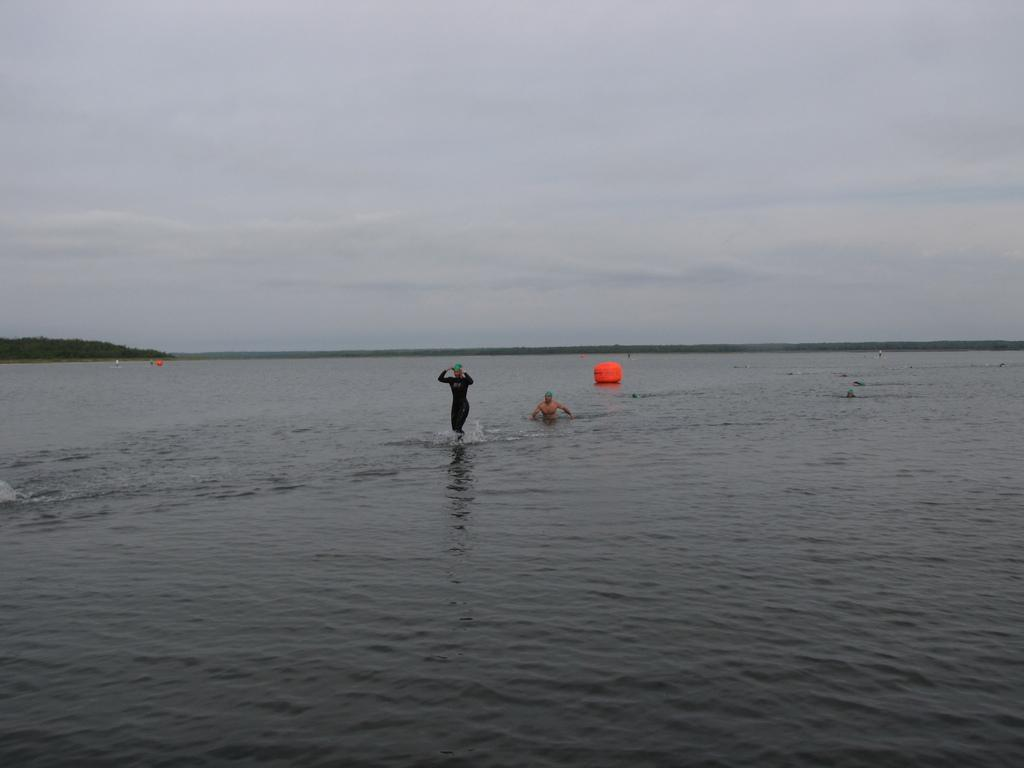Where was the image taken? The image was clicked outside the city. What are the two persons in the image doing? The two persons are in a water body in the center of the image. What is present in the water body with the persons? There is an object in the water body. What can be seen in the background of the image? There is a sky and hills visible in the background of the image. What type of snakes can be seen exchanging views in the image? There are no snakes present in the image, nor is there any exchange of views. 